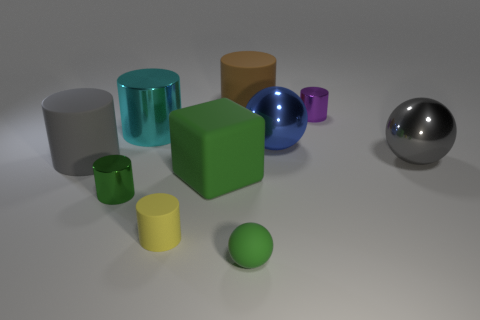Subtract all green spheres. How many spheres are left? 2 Subtract all purple cylinders. How many cylinders are left? 5 Subtract 1 balls. How many balls are left? 2 Subtract all spheres. How many objects are left? 7 Subtract 1 cyan cylinders. How many objects are left? 9 Subtract all green cylinders. Subtract all cyan blocks. How many cylinders are left? 5 Subtract all large gray cylinders. Subtract all balls. How many objects are left? 6 Add 3 tiny purple cylinders. How many tiny purple cylinders are left? 4 Add 9 yellow objects. How many yellow objects exist? 10 